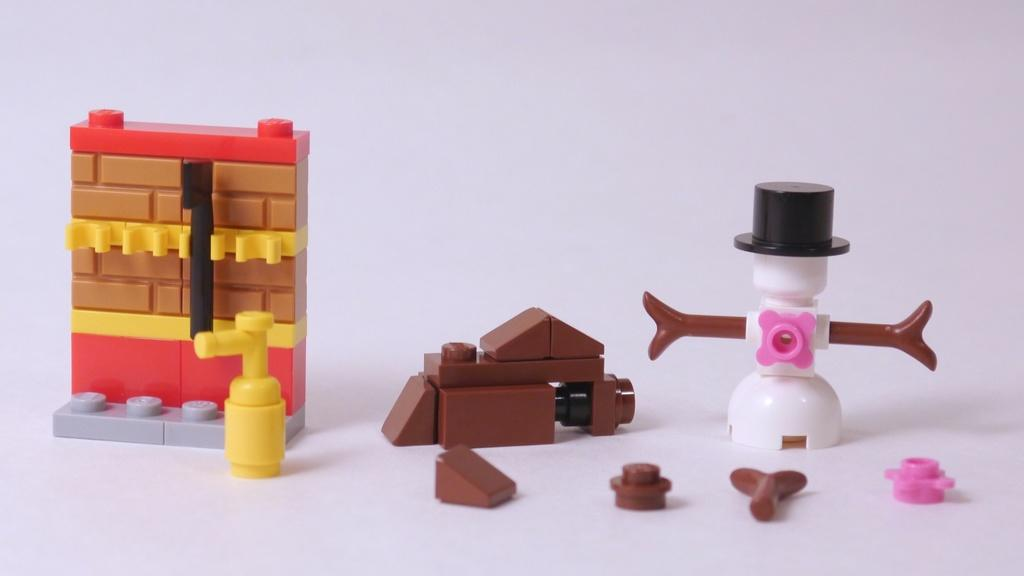What objects are present in the image? There are toys in the image. Where are the toys located? The toys are placed on a surface. What type of voice can be heard coming from the toys in the image? There is no indication in the image that the toys are making any sounds or have a voice. 